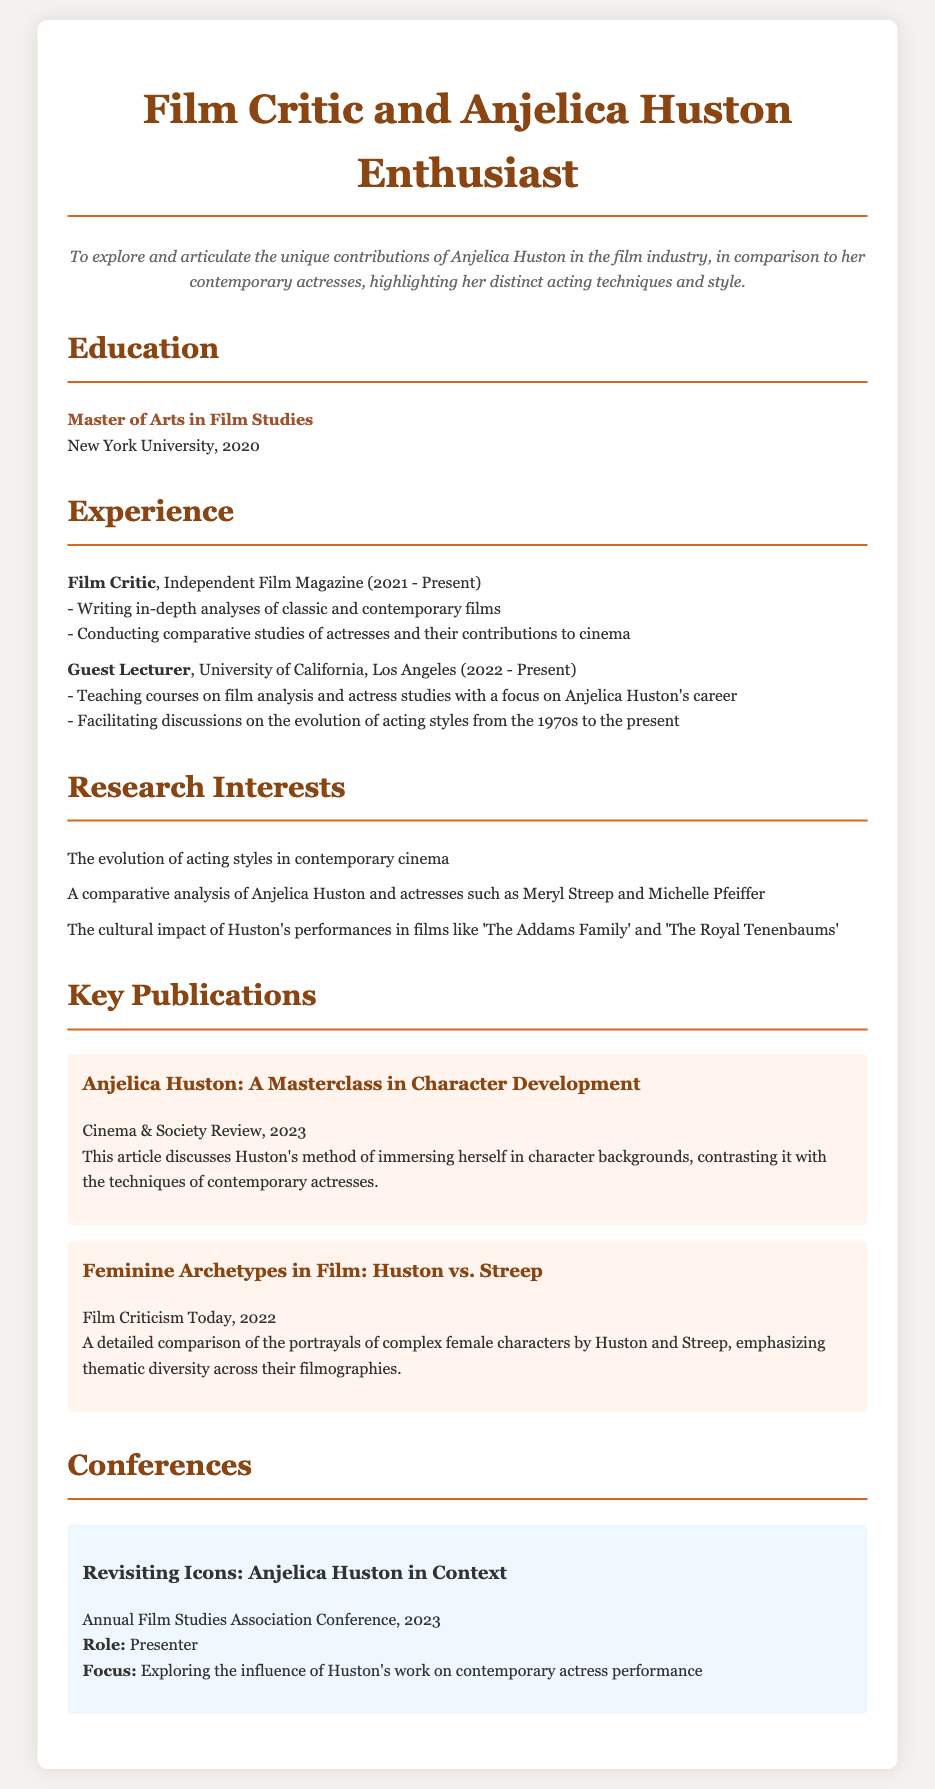what is the highest degree obtained? The highest degree mentioned is a Master of Arts in Film Studies.
Answer: Master of Arts in Film Studies who is currently teaching at UCLA? The document states that the Guest Lecturer position is held at UCLA, which indicates that the author is teaching there.
Answer: Guest Lecturer what year did the author start working as a film critic? The author began working at Independent Film Magazine in 2021.
Answer: 2021 which publication discusses Anjelica Huston's character development? The article titled "Anjelica Huston: A Masterclass in Character Development" talks about this subject.
Answer: Anjelica Huston: A Masterclass in Character Development how many research interests are listed? There are three research interests mentioned in the document.
Answer: Three what conference did the author present at in 2023? The conference where the author presented is titled "Revisiting Icons: Anjelica Huston in Context."
Answer: Revisiting Icons: Anjelica Huston in Context who is compared to Anjelica Huston in the listed publications? Meryl Streep is mentioned as a comparative actress in multiple publications.
Answer: Meryl Streep what is the focus of the teaching at UCLA? The focus of the teaching includes film analysis and actress studies with an emphasis on Anjelica Huston.
Answer: Anjelica Huston's career 